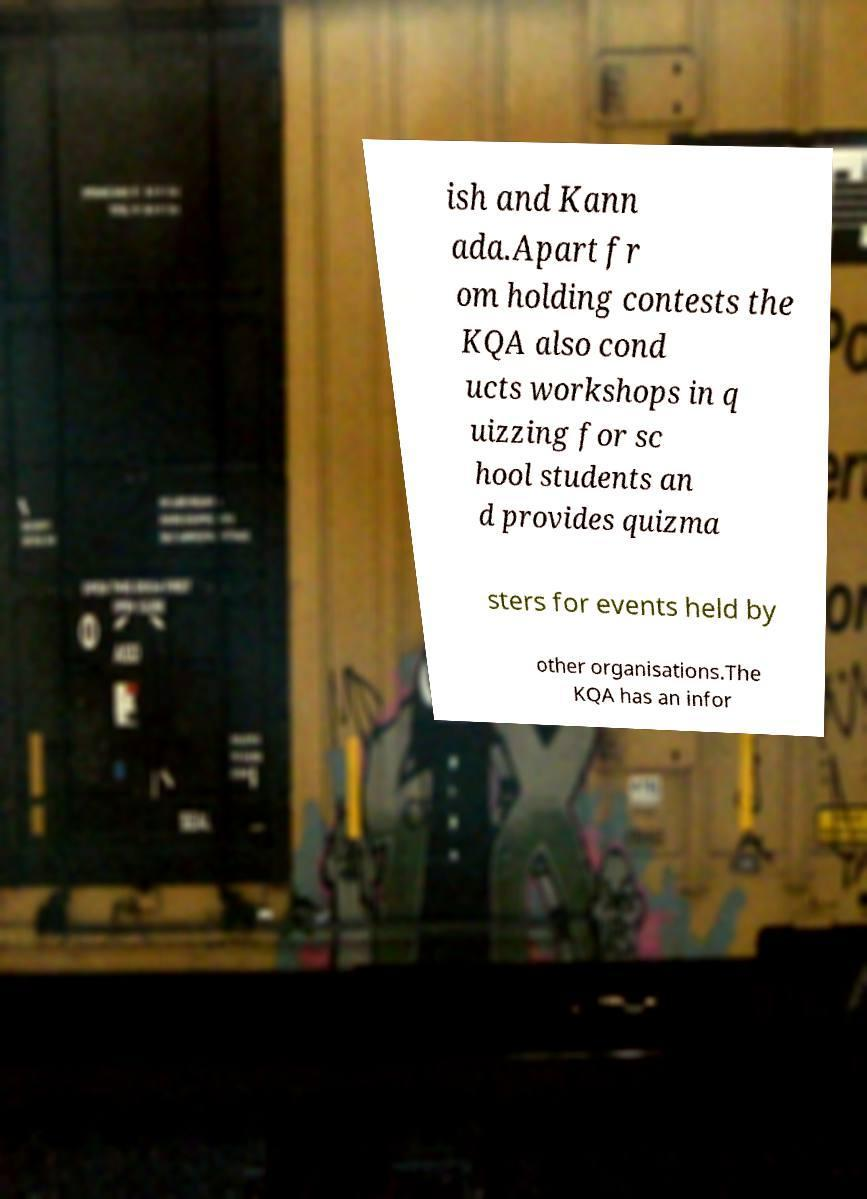For documentation purposes, I need the text within this image transcribed. Could you provide that? ish and Kann ada.Apart fr om holding contests the KQA also cond ucts workshops in q uizzing for sc hool students an d provides quizma sters for events held by other organisations.The KQA has an infor 